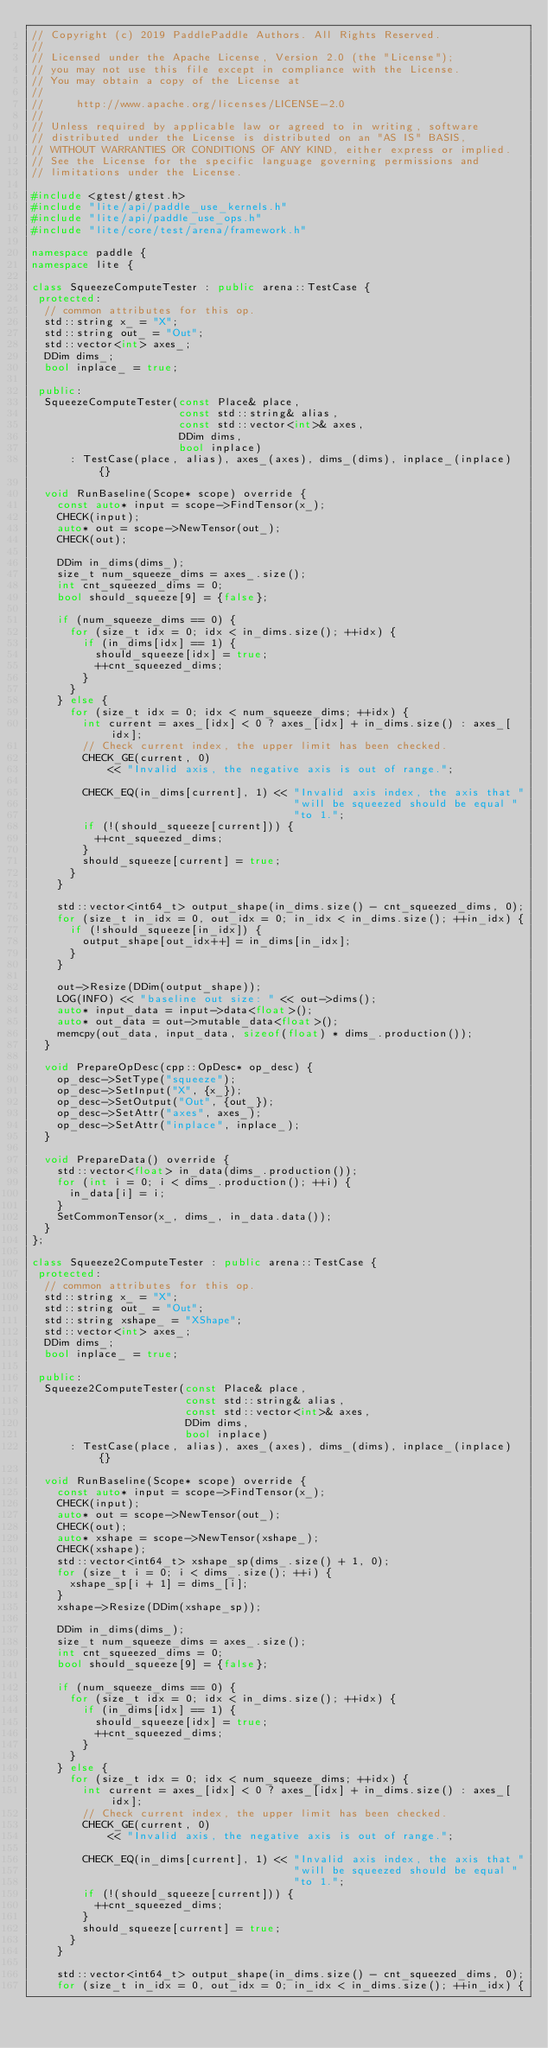Convert code to text. <code><loc_0><loc_0><loc_500><loc_500><_C++_>// Copyright (c) 2019 PaddlePaddle Authors. All Rights Reserved.
//
// Licensed under the Apache License, Version 2.0 (the "License");
// you may not use this file except in compliance with the License.
// You may obtain a copy of the License at
//
//     http://www.apache.org/licenses/LICENSE-2.0
//
// Unless required by applicable law or agreed to in writing, software
// distributed under the License is distributed on an "AS IS" BASIS,
// WITHOUT WARRANTIES OR CONDITIONS OF ANY KIND, either express or implied.
// See the License for the specific language governing permissions and
// limitations under the License.

#include <gtest/gtest.h>
#include "lite/api/paddle_use_kernels.h"
#include "lite/api/paddle_use_ops.h"
#include "lite/core/test/arena/framework.h"

namespace paddle {
namespace lite {

class SqueezeComputeTester : public arena::TestCase {
 protected:
  // common attributes for this op.
  std::string x_ = "X";
  std::string out_ = "Out";
  std::vector<int> axes_;
  DDim dims_;
  bool inplace_ = true;

 public:
  SqueezeComputeTester(const Place& place,
                       const std::string& alias,
                       const std::vector<int>& axes,
                       DDim dims,
                       bool inplace)
      : TestCase(place, alias), axes_(axes), dims_(dims), inplace_(inplace) {}

  void RunBaseline(Scope* scope) override {
    const auto* input = scope->FindTensor(x_);
    CHECK(input);
    auto* out = scope->NewTensor(out_);
    CHECK(out);

    DDim in_dims(dims_);
    size_t num_squeeze_dims = axes_.size();
    int cnt_squeezed_dims = 0;
    bool should_squeeze[9] = {false};

    if (num_squeeze_dims == 0) {
      for (size_t idx = 0; idx < in_dims.size(); ++idx) {
        if (in_dims[idx] == 1) {
          should_squeeze[idx] = true;
          ++cnt_squeezed_dims;
        }
      }
    } else {
      for (size_t idx = 0; idx < num_squeeze_dims; ++idx) {
        int current = axes_[idx] < 0 ? axes_[idx] + in_dims.size() : axes_[idx];
        // Check current index, the upper limit has been checked.
        CHECK_GE(current, 0)
            << "Invalid axis, the negative axis is out of range.";

        CHECK_EQ(in_dims[current], 1) << "Invalid axis index, the axis that "
                                         "will be squeezed should be equal "
                                         "to 1.";
        if (!(should_squeeze[current])) {
          ++cnt_squeezed_dims;
        }
        should_squeeze[current] = true;
      }
    }

    std::vector<int64_t> output_shape(in_dims.size() - cnt_squeezed_dims, 0);
    for (size_t in_idx = 0, out_idx = 0; in_idx < in_dims.size(); ++in_idx) {
      if (!should_squeeze[in_idx]) {
        output_shape[out_idx++] = in_dims[in_idx];
      }
    }

    out->Resize(DDim(output_shape));
    LOG(INFO) << "baseline out size: " << out->dims();
    auto* input_data = input->data<float>();
    auto* out_data = out->mutable_data<float>();
    memcpy(out_data, input_data, sizeof(float) * dims_.production());
  }

  void PrepareOpDesc(cpp::OpDesc* op_desc) {
    op_desc->SetType("squeeze");
    op_desc->SetInput("X", {x_});
    op_desc->SetOutput("Out", {out_});
    op_desc->SetAttr("axes", axes_);
    op_desc->SetAttr("inplace", inplace_);
  }

  void PrepareData() override {
    std::vector<float> in_data(dims_.production());
    for (int i = 0; i < dims_.production(); ++i) {
      in_data[i] = i;
    }
    SetCommonTensor(x_, dims_, in_data.data());
  }
};

class Squeeze2ComputeTester : public arena::TestCase {
 protected:
  // common attributes for this op.
  std::string x_ = "X";
  std::string out_ = "Out";
  std::string xshape_ = "XShape";
  std::vector<int> axes_;
  DDim dims_;
  bool inplace_ = true;

 public:
  Squeeze2ComputeTester(const Place& place,
                        const std::string& alias,
                        const std::vector<int>& axes,
                        DDim dims,
                        bool inplace)
      : TestCase(place, alias), axes_(axes), dims_(dims), inplace_(inplace) {}

  void RunBaseline(Scope* scope) override {
    const auto* input = scope->FindTensor(x_);
    CHECK(input);
    auto* out = scope->NewTensor(out_);
    CHECK(out);
    auto* xshape = scope->NewTensor(xshape_);
    CHECK(xshape);
    std::vector<int64_t> xshape_sp(dims_.size() + 1, 0);
    for (size_t i = 0; i < dims_.size(); ++i) {
      xshape_sp[i + 1] = dims_[i];
    }
    xshape->Resize(DDim(xshape_sp));

    DDim in_dims(dims_);
    size_t num_squeeze_dims = axes_.size();
    int cnt_squeezed_dims = 0;
    bool should_squeeze[9] = {false};

    if (num_squeeze_dims == 0) {
      for (size_t idx = 0; idx < in_dims.size(); ++idx) {
        if (in_dims[idx] == 1) {
          should_squeeze[idx] = true;
          ++cnt_squeezed_dims;
        }
      }
    } else {
      for (size_t idx = 0; idx < num_squeeze_dims; ++idx) {
        int current = axes_[idx] < 0 ? axes_[idx] + in_dims.size() : axes_[idx];
        // Check current index, the upper limit has been checked.
        CHECK_GE(current, 0)
            << "Invalid axis, the negative axis is out of range.";

        CHECK_EQ(in_dims[current], 1) << "Invalid axis index, the axis that "
                                         "will be squeezed should be equal "
                                         "to 1.";
        if (!(should_squeeze[current])) {
          ++cnt_squeezed_dims;
        }
        should_squeeze[current] = true;
      }
    }

    std::vector<int64_t> output_shape(in_dims.size() - cnt_squeezed_dims, 0);
    for (size_t in_idx = 0, out_idx = 0; in_idx < in_dims.size(); ++in_idx) {</code> 